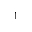Convert formula to latex. <formula><loc_0><loc_0><loc_500><loc_500>^ { 1 }</formula> 